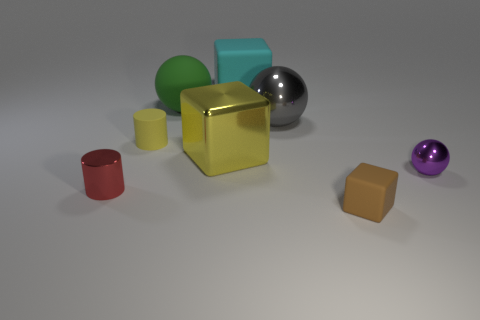Subtract all matte blocks. How many blocks are left? 1 Add 2 purple metal cylinders. How many objects exist? 10 Subtract all cylinders. How many objects are left? 6 Subtract 1 cylinders. How many cylinders are left? 1 Subtract all blue spheres. Subtract all red blocks. How many spheres are left? 3 Subtract all yellow balls. How many red cubes are left? 0 Subtract all gray metallic objects. Subtract all brown objects. How many objects are left? 6 Add 2 spheres. How many spheres are left? 5 Add 7 large green matte objects. How many large green matte objects exist? 8 Subtract all yellow cubes. How many cubes are left? 2 